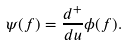Convert formula to latex. <formula><loc_0><loc_0><loc_500><loc_500>\psi ( f ) = \frac { d ^ { + } } { d u } \phi ( f ) .</formula> 